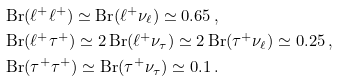Convert formula to latex. <formula><loc_0><loc_0><loc_500><loc_500>& \text {Br} ( \ell ^ { + } \ell ^ { + } ) \simeq \text {Br} ( \ell ^ { + } \nu _ { \ell } ) \simeq 0 . 6 5 \, , \\ & \text {Br} ( \ell ^ { + } \tau ^ { + } ) \simeq 2 \, \text {Br} ( \ell ^ { + } \nu _ { \tau } ) \simeq 2 \, \text {Br} ( \tau ^ { + } \nu _ { \ell } ) \simeq 0 . 2 5 \, , \\ & \text {Br} ( \tau ^ { + } \tau ^ { + } ) \simeq \text {Br} ( \tau ^ { + } \nu _ { \tau } ) \simeq 0 . 1 \, .</formula> 